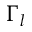<formula> <loc_0><loc_0><loc_500><loc_500>\Gamma _ { l }</formula> 